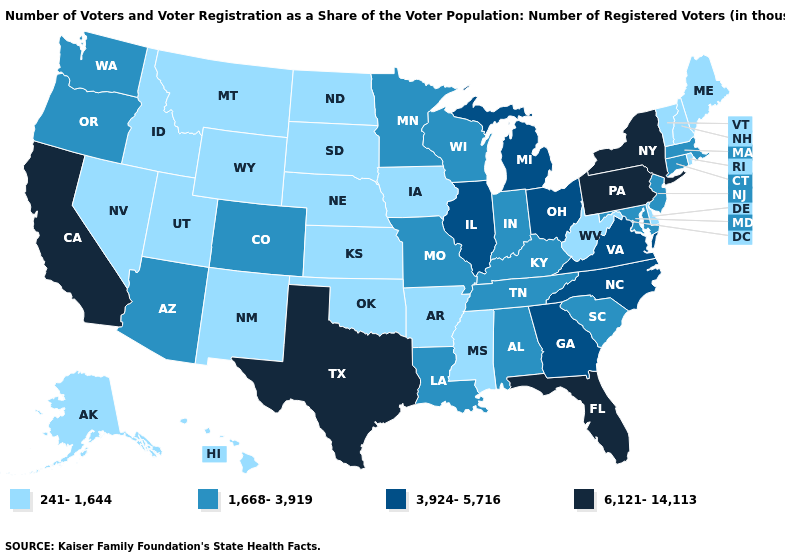Which states have the highest value in the USA?
Answer briefly. California, Florida, New York, Pennsylvania, Texas. Among the states that border Mississippi , which have the highest value?
Keep it brief. Alabama, Louisiana, Tennessee. Does Kansas have the same value as North Carolina?
Concise answer only. No. What is the lowest value in the USA?
Write a very short answer. 241-1,644. What is the value of Indiana?
Keep it brief. 1,668-3,919. Which states have the lowest value in the USA?
Keep it brief. Alaska, Arkansas, Delaware, Hawaii, Idaho, Iowa, Kansas, Maine, Mississippi, Montana, Nebraska, Nevada, New Hampshire, New Mexico, North Dakota, Oklahoma, Rhode Island, South Dakota, Utah, Vermont, West Virginia, Wyoming. What is the highest value in the USA?
Concise answer only. 6,121-14,113. Name the states that have a value in the range 3,924-5,716?
Answer briefly. Georgia, Illinois, Michigan, North Carolina, Ohio, Virginia. Name the states that have a value in the range 241-1,644?
Give a very brief answer. Alaska, Arkansas, Delaware, Hawaii, Idaho, Iowa, Kansas, Maine, Mississippi, Montana, Nebraska, Nevada, New Hampshire, New Mexico, North Dakota, Oklahoma, Rhode Island, South Dakota, Utah, Vermont, West Virginia, Wyoming. Which states have the highest value in the USA?
Keep it brief. California, Florida, New York, Pennsylvania, Texas. Name the states that have a value in the range 1,668-3,919?
Answer briefly. Alabama, Arizona, Colorado, Connecticut, Indiana, Kentucky, Louisiana, Maryland, Massachusetts, Minnesota, Missouri, New Jersey, Oregon, South Carolina, Tennessee, Washington, Wisconsin. Does the first symbol in the legend represent the smallest category?
Quick response, please. Yes. Which states hav the highest value in the West?
Write a very short answer. California. What is the value of Colorado?
Concise answer only. 1,668-3,919. Does Nebraska have the lowest value in the MidWest?
Concise answer only. Yes. 